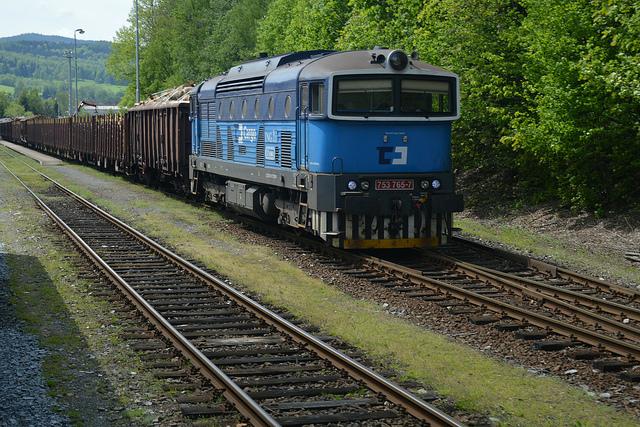What color is the train?
Short answer required. Blue. What is the train hauling?
Short answer required. Wood. What numbers are at the front of the train?
Answer briefly. 7537657. Is this train carrying passengers or cargo?
Keep it brief. Cargo. Could this train be electrically powered?
Give a very brief answer. Yes. Is this a passenger train?
Answer briefly. No. What does this train carry?
Keep it brief. Freight. 